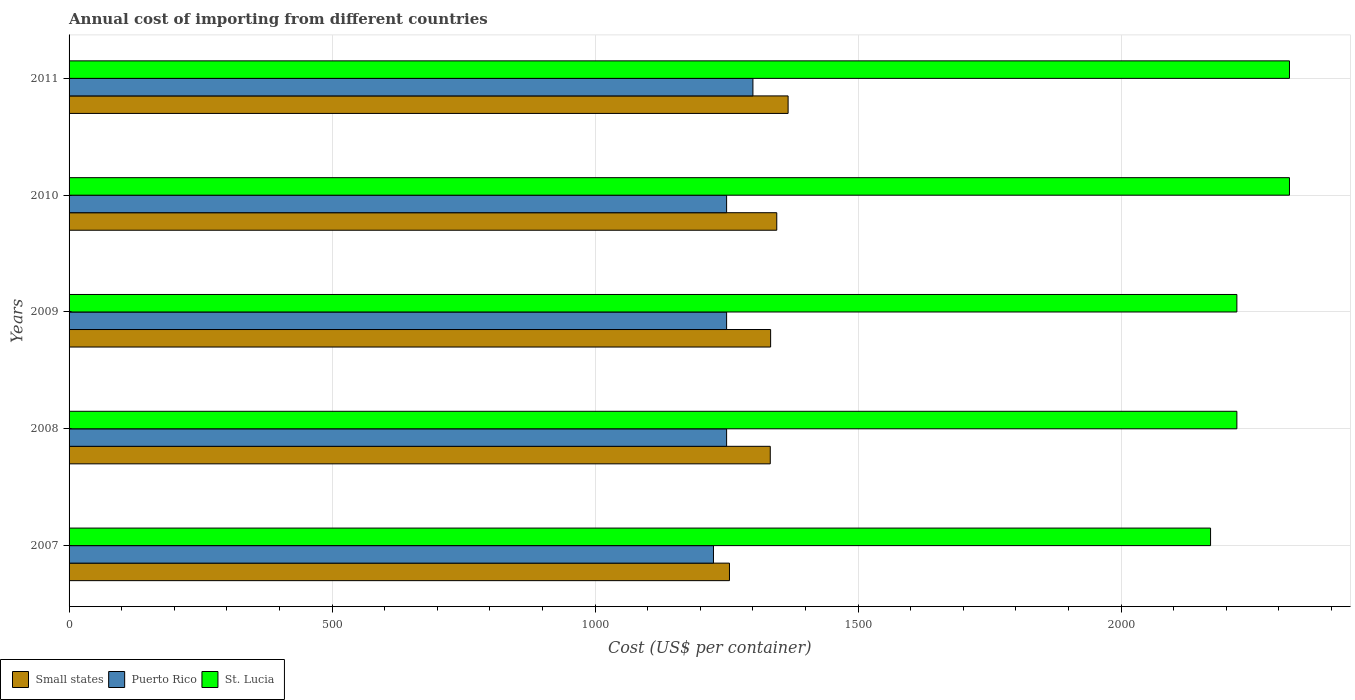How many different coloured bars are there?
Offer a terse response. 3. How many groups of bars are there?
Your answer should be compact. 5. Are the number of bars per tick equal to the number of legend labels?
Give a very brief answer. Yes. Are the number of bars on each tick of the Y-axis equal?
Ensure brevity in your answer.  Yes. How many bars are there on the 1st tick from the bottom?
Provide a short and direct response. 3. What is the total annual cost of importing in Small states in 2008?
Offer a very short reply. 1332.97. Across all years, what is the maximum total annual cost of importing in Puerto Rico?
Make the answer very short. 1300. Across all years, what is the minimum total annual cost of importing in St. Lucia?
Your answer should be compact. 2170. In which year was the total annual cost of importing in Puerto Rico maximum?
Give a very brief answer. 2011. What is the total total annual cost of importing in Puerto Rico in the graph?
Offer a terse response. 6275. What is the difference between the total annual cost of importing in St. Lucia in 2009 and that in 2011?
Provide a succinct answer. -100. What is the difference between the total annual cost of importing in Puerto Rico in 2011 and the total annual cost of importing in Small states in 2008?
Your response must be concise. -32.97. What is the average total annual cost of importing in St. Lucia per year?
Offer a terse response. 2250. In the year 2011, what is the difference between the total annual cost of importing in St. Lucia and total annual cost of importing in Small states?
Provide a succinct answer. 953.1. In how many years, is the total annual cost of importing in Puerto Rico greater than 300 US$?
Your answer should be compact. 5. What is the ratio of the total annual cost of importing in St. Lucia in 2009 to that in 2011?
Offer a terse response. 0.96. What is the difference between the highest and the second highest total annual cost of importing in Small states?
Your response must be concise. 21.57. What is the difference between the highest and the lowest total annual cost of importing in St. Lucia?
Offer a very short reply. 150. In how many years, is the total annual cost of importing in St. Lucia greater than the average total annual cost of importing in St. Lucia taken over all years?
Your answer should be very brief. 2. What does the 2nd bar from the top in 2010 represents?
Keep it short and to the point. Puerto Rico. What does the 3rd bar from the bottom in 2007 represents?
Provide a succinct answer. St. Lucia. Are all the bars in the graph horizontal?
Ensure brevity in your answer.  Yes. How many years are there in the graph?
Your answer should be very brief. 5. What is the difference between two consecutive major ticks on the X-axis?
Your answer should be very brief. 500. Does the graph contain any zero values?
Provide a short and direct response. No. Does the graph contain grids?
Your response must be concise. Yes. Where does the legend appear in the graph?
Your response must be concise. Bottom left. What is the title of the graph?
Provide a succinct answer. Annual cost of importing from different countries. What is the label or title of the X-axis?
Ensure brevity in your answer.  Cost (US$ per container). What is the Cost (US$ per container) of Small states in 2007?
Ensure brevity in your answer.  1255.44. What is the Cost (US$ per container) in Puerto Rico in 2007?
Keep it short and to the point. 1225. What is the Cost (US$ per container) in St. Lucia in 2007?
Provide a succinct answer. 2170. What is the Cost (US$ per container) in Small states in 2008?
Give a very brief answer. 1332.97. What is the Cost (US$ per container) in Puerto Rico in 2008?
Your response must be concise. 1250. What is the Cost (US$ per container) in St. Lucia in 2008?
Your answer should be compact. 2220. What is the Cost (US$ per container) in Small states in 2009?
Your answer should be very brief. 1333.67. What is the Cost (US$ per container) of Puerto Rico in 2009?
Keep it short and to the point. 1250. What is the Cost (US$ per container) in St. Lucia in 2009?
Keep it short and to the point. 2220. What is the Cost (US$ per container) of Small states in 2010?
Give a very brief answer. 1345.33. What is the Cost (US$ per container) in Puerto Rico in 2010?
Offer a very short reply. 1250. What is the Cost (US$ per container) in St. Lucia in 2010?
Keep it short and to the point. 2320. What is the Cost (US$ per container) in Small states in 2011?
Offer a terse response. 1366.9. What is the Cost (US$ per container) of Puerto Rico in 2011?
Your answer should be compact. 1300. What is the Cost (US$ per container) in St. Lucia in 2011?
Give a very brief answer. 2320. Across all years, what is the maximum Cost (US$ per container) of Small states?
Provide a short and direct response. 1366.9. Across all years, what is the maximum Cost (US$ per container) of Puerto Rico?
Provide a succinct answer. 1300. Across all years, what is the maximum Cost (US$ per container) in St. Lucia?
Provide a succinct answer. 2320. Across all years, what is the minimum Cost (US$ per container) in Small states?
Offer a very short reply. 1255.44. Across all years, what is the minimum Cost (US$ per container) in Puerto Rico?
Your response must be concise. 1225. Across all years, what is the minimum Cost (US$ per container) in St. Lucia?
Keep it short and to the point. 2170. What is the total Cost (US$ per container) in Small states in the graph?
Offer a very short reply. 6634.31. What is the total Cost (US$ per container) of Puerto Rico in the graph?
Provide a succinct answer. 6275. What is the total Cost (US$ per container) in St. Lucia in the graph?
Your answer should be very brief. 1.12e+04. What is the difference between the Cost (US$ per container) of Small states in 2007 and that in 2008?
Give a very brief answer. -77.54. What is the difference between the Cost (US$ per container) of St. Lucia in 2007 and that in 2008?
Make the answer very short. -50. What is the difference between the Cost (US$ per container) in Small states in 2007 and that in 2009?
Provide a succinct answer. -78.23. What is the difference between the Cost (US$ per container) of Puerto Rico in 2007 and that in 2009?
Your response must be concise. -25. What is the difference between the Cost (US$ per container) of Small states in 2007 and that in 2010?
Keep it short and to the point. -89.9. What is the difference between the Cost (US$ per container) in St. Lucia in 2007 and that in 2010?
Make the answer very short. -150. What is the difference between the Cost (US$ per container) of Small states in 2007 and that in 2011?
Your answer should be compact. -111.46. What is the difference between the Cost (US$ per container) in Puerto Rico in 2007 and that in 2011?
Ensure brevity in your answer.  -75. What is the difference between the Cost (US$ per container) in St. Lucia in 2007 and that in 2011?
Offer a very short reply. -150. What is the difference between the Cost (US$ per container) in Small states in 2008 and that in 2009?
Keep it short and to the point. -0.69. What is the difference between the Cost (US$ per container) in St. Lucia in 2008 and that in 2009?
Offer a very short reply. 0. What is the difference between the Cost (US$ per container) in Small states in 2008 and that in 2010?
Provide a short and direct response. -12.36. What is the difference between the Cost (US$ per container) of St. Lucia in 2008 and that in 2010?
Your answer should be very brief. -100. What is the difference between the Cost (US$ per container) of Small states in 2008 and that in 2011?
Provide a succinct answer. -33.93. What is the difference between the Cost (US$ per container) of St. Lucia in 2008 and that in 2011?
Make the answer very short. -100. What is the difference between the Cost (US$ per container) in Small states in 2009 and that in 2010?
Provide a short and direct response. -11.67. What is the difference between the Cost (US$ per container) in St. Lucia in 2009 and that in 2010?
Provide a short and direct response. -100. What is the difference between the Cost (US$ per container) of Small states in 2009 and that in 2011?
Provide a succinct answer. -33.23. What is the difference between the Cost (US$ per container) in Puerto Rico in 2009 and that in 2011?
Make the answer very short. -50. What is the difference between the Cost (US$ per container) of St. Lucia in 2009 and that in 2011?
Offer a terse response. -100. What is the difference between the Cost (US$ per container) of Small states in 2010 and that in 2011?
Make the answer very short. -21.57. What is the difference between the Cost (US$ per container) of Small states in 2007 and the Cost (US$ per container) of Puerto Rico in 2008?
Provide a short and direct response. 5.44. What is the difference between the Cost (US$ per container) of Small states in 2007 and the Cost (US$ per container) of St. Lucia in 2008?
Your answer should be compact. -964.56. What is the difference between the Cost (US$ per container) of Puerto Rico in 2007 and the Cost (US$ per container) of St. Lucia in 2008?
Ensure brevity in your answer.  -995. What is the difference between the Cost (US$ per container) in Small states in 2007 and the Cost (US$ per container) in Puerto Rico in 2009?
Your answer should be very brief. 5.44. What is the difference between the Cost (US$ per container) in Small states in 2007 and the Cost (US$ per container) in St. Lucia in 2009?
Your answer should be compact. -964.56. What is the difference between the Cost (US$ per container) of Puerto Rico in 2007 and the Cost (US$ per container) of St. Lucia in 2009?
Make the answer very short. -995. What is the difference between the Cost (US$ per container) in Small states in 2007 and the Cost (US$ per container) in Puerto Rico in 2010?
Your answer should be compact. 5.44. What is the difference between the Cost (US$ per container) of Small states in 2007 and the Cost (US$ per container) of St. Lucia in 2010?
Provide a succinct answer. -1064.56. What is the difference between the Cost (US$ per container) of Puerto Rico in 2007 and the Cost (US$ per container) of St. Lucia in 2010?
Your answer should be compact. -1095. What is the difference between the Cost (US$ per container) of Small states in 2007 and the Cost (US$ per container) of Puerto Rico in 2011?
Provide a short and direct response. -44.56. What is the difference between the Cost (US$ per container) in Small states in 2007 and the Cost (US$ per container) in St. Lucia in 2011?
Keep it short and to the point. -1064.56. What is the difference between the Cost (US$ per container) of Puerto Rico in 2007 and the Cost (US$ per container) of St. Lucia in 2011?
Your response must be concise. -1095. What is the difference between the Cost (US$ per container) of Small states in 2008 and the Cost (US$ per container) of Puerto Rico in 2009?
Your answer should be compact. 82.97. What is the difference between the Cost (US$ per container) in Small states in 2008 and the Cost (US$ per container) in St. Lucia in 2009?
Your answer should be compact. -887.03. What is the difference between the Cost (US$ per container) in Puerto Rico in 2008 and the Cost (US$ per container) in St. Lucia in 2009?
Your response must be concise. -970. What is the difference between the Cost (US$ per container) of Small states in 2008 and the Cost (US$ per container) of Puerto Rico in 2010?
Your answer should be compact. 82.97. What is the difference between the Cost (US$ per container) in Small states in 2008 and the Cost (US$ per container) in St. Lucia in 2010?
Offer a terse response. -987.03. What is the difference between the Cost (US$ per container) in Puerto Rico in 2008 and the Cost (US$ per container) in St. Lucia in 2010?
Provide a short and direct response. -1070. What is the difference between the Cost (US$ per container) of Small states in 2008 and the Cost (US$ per container) of Puerto Rico in 2011?
Your response must be concise. 32.97. What is the difference between the Cost (US$ per container) of Small states in 2008 and the Cost (US$ per container) of St. Lucia in 2011?
Keep it short and to the point. -987.03. What is the difference between the Cost (US$ per container) in Puerto Rico in 2008 and the Cost (US$ per container) in St. Lucia in 2011?
Offer a terse response. -1070. What is the difference between the Cost (US$ per container) in Small states in 2009 and the Cost (US$ per container) in Puerto Rico in 2010?
Your answer should be very brief. 83.67. What is the difference between the Cost (US$ per container) of Small states in 2009 and the Cost (US$ per container) of St. Lucia in 2010?
Your answer should be compact. -986.33. What is the difference between the Cost (US$ per container) of Puerto Rico in 2009 and the Cost (US$ per container) of St. Lucia in 2010?
Your answer should be very brief. -1070. What is the difference between the Cost (US$ per container) of Small states in 2009 and the Cost (US$ per container) of Puerto Rico in 2011?
Offer a terse response. 33.67. What is the difference between the Cost (US$ per container) of Small states in 2009 and the Cost (US$ per container) of St. Lucia in 2011?
Your answer should be very brief. -986.33. What is the difference between the Cost (US$ per container) of Puerto Rico in 2009 and the Cost (US$ per container) of St. Lucia in 2011?
Keep it short and to the point. -1070. What is the difference between the Cost (US$ per container) in Small states in 2010 and the Cost (US$ per container) in Puerto Rico in 2011?
Offer a very short reply. 45.33. What is the difference between the Cost (US$ per container) in Small states in 2010 and the Cost (US$ per container) in St. Lucia in 2011?
Make the answer very short. -974.67. What is the difference between the Cost (US$ per container) of Puerto Rico in 2010 and the Cost (US$ per container) of St. Lucia in 2011?
Offer a terse response. -1070. What is the average Cost (US$ per container) in Small states per year?
Provide a short and direct response. 1326.86. What is the average Cost (US$ per container) of Puerto Rico per year?
Provide a succinct answer. 1255. What is the average Cost (US$ per container) in St. Lucia per year?
Give a very brief answer. 2250. In the year 2007, what is the difference between the Cost (US$ per container) of Small states and Cost (US$ per container) of Puerto Rico?
Keep it short and to the point. 30.44. In the year 2007, what is the difference between the Cost (US$ per container) in Small states and Cost (US$ per container) in St. Lucia?
Your answer should be compact. -914.56. In the year 2007, what is the difference between the Cost (US$ per container) of Puerto Rico and Cost (US$ per container) of St. Lucia?
Your response must be concise. -945. In the year 2008, what is the difference between the Cost (US$ per container) of Small states and Cost (US$ per container) of Puerto Rico?
Keep it short and to the point. 82.97. In the year 2008, what is the difference between the Cost (US$ per container) in Small states and Cost (US$ per container) in St. Lucia?
Keep it short and to the point. -887.03. In the year 2008, what is the difference between the Cost (US$ per container) in Puerto Rico and Cost (US$ per container) in St. Lucia?
Offer a very short reply. -970. In the year 2009, what is the difference between the Cost (US$ per container) of Small states and Cost (US$ per container) of Puerto Rico?
Provide a succinct answer. 83.67. In the year 2009, what is the difference between the Cost (US$ per container) in Small states and Cost (US$ per container) in St. Lucia?
Give a very brief answer. -886.33. In the year 2009, what is the difference between the Cost (US$ per container) in Puerto Rico and Cost (US$ per container) in St. Lucia?
Keep it short and to the point. -970. In the year 2010, what is the difference between the Cost (US$ per container) of Small states and Cost (US$ per container) of Puerto Rico?
Keep it short and to the point. 95.33. In the year 2010, what is the difference between the Cost (US$ per container) of Small states and Cost (US$ per container) of St. Lucia?
Your answer should be compact. -974.67. In the year 2010, what is the difference between the Cost (US$ per container) in Puerto Rico and Cost (US$ per container) in St. Lucia?
Offer a terse response. -1070. In the year 2011, what is the difference between the Cost (US$ per container) of Small states and Cost (US$ per container) of Puerto Rico?
Offer a terse response. 66.9. In the year 2011, what is the difference between the Cost (US$ per container) of Small states and Cost (US$ per container) of St. Lucia?
Offer a very short reply. -953.1. In the year 2011, what is the difference between the Cost (US$ per container) of Puerto Rico and Cost (US$ per container) of St. Lucia?
Provide a short and direct response. -1020. What is the ratio of the Cost (US$ per container) of Small states in 2007 to that in 2008?
Provide a succinct answer. 0.94. What is the ratio of the Cost (US$ per container) in Puerto Rico in 2007 to that in 2008?
Your response must be concise. 0.98. What is the ratio of the Cost (US$ per container) of St. Lucia in 2007 to that in 2008?
Offer a very short reply. 0.98. What is the ratio of the Cost (US$ per container) in Small states in 2007 to that in 2009?
Ensure brevity in your answer.  0.94. What is the ratio of the Cost (US$ per container) of Puerto Rico in 2007 to that in 2009?
Make the answer very short. 0.98. What is the ratio of the Cost (US$ per container) of St. Lucia in 2007 to that in 2009?
Offer a terse response. 0.98. What is the ratio of the Cost (US$ per container) of Small states in 2007 to that in 2010?
Offer a terse response. 0.93. What is the ratio of the Cost (US$ per container) in Puerto Rico in 2007 to that in 2010?
Provide a succinct answer. 0.98. What is the ratio of the Cost (US$ per container) of St. Lucia in 2007 to that in 2010?
Your response must be concise. 0.94. What is the ratio of the Cost (US$ per container) of Small states in 2007 to that in 2011?
Ensure brevity in your answer.  0.92. What is the ratio of the Cost (US$ per container) of Puerto Rico in 2007 to that in 2011?
Give a very brief answer. 0.94. What is the ratio of the Cost (US$ per container) in St. Lucia in 2007 to that in 2011?
Your answer should be compact. 0.94. What is the ratio of the Cost (US$ per container) in Small states in 2008 to that in 2009?
Your response must be concise. 1. What is the ratio of the Cost (US$ per container) in St. Lucia in 2008 to that in 2009?
Your answer should be very brief. 1. What is the ratio of the Cost (US$ per container) in Small states in 2008 to that in 2010?
Make the answer very short. 0.99. What is the ratio of the Cost (US$ per container) in Puerto Rico in 2008 to that in 2010?
Offer a terse response. 1. What is the ratio of the Cost (US$ per container) of St. Lucia in 2008 to that in 2010?
Make the answer very short. 0.96. What is the ratio of the Cost (US$ per container) of Small states in 2008 to that in 2011?
Give a very brief answer. 0.98. What is the ratio of the Cost (US$ per container) in Puerto Rico in 2008 to that in 2011?
Your answer should be compact. 0.96. What is the ratio of the Cost (US$ per container) in St. Lucia in 2008 to that in 2011?
Provide a succinct answer. 0.96. What is the ratio of the Cost (US$ per container) in Puerto Rico in 2009 to that in 2010?
Keep it short and to the point. 1. What is the ratio of the Cost (US$ per container) in St. Lucia in 2009 to that in 2010?
Provide a short and direct response. 0.96. What is the ratio of the Cost (US$ per container) of Small states in 2009 to that in 2011?
Your answer should be very brief. 0.98. What is the ratio of the Cost (US$ per container) of Puerto Rico in 2009 to that in 2011?
Provide a short and direct response. 0.96. What is the ratio of the Cost (US$ per container) of St. Lucia in 2009 to that in 2011?
Your answer should be compact. 0.96. What is the ratio of the Cost (US$ per container) of Small states in 2010 to that in 2011?
Your response must be concise. 0.98. What is the ratio of the Cost (US$ per container) of Puerto Rico in 2010 to that in 2011?
Provide a succinct answer. 0.96. What is the ratio of the Cost (US$ per container) in St. Lucia in 2010 to that in 2011?
Give a very brief answer. 1. What is the difference between the highest and the second highest Cost (US$ per container) of Small states?
Make the answer very short. 21.57. What is the difference between the highest and the second highest Cost (US$ per container) of Puerto Rico?
Provide a succinct answer. 50. What is the difference between the highest and the lowest Cost (US$ per container) of Small states?
Keep it short and to the point. 111.46. What is the difference between the highest and the lowest Cost (US$ per container) of Puerto Rico?
Make the answer very short. 75. What is the difference between the highest and the lowest Cost (US$ per container) of St. Lucia?
Provide a succinct answer. 150. 